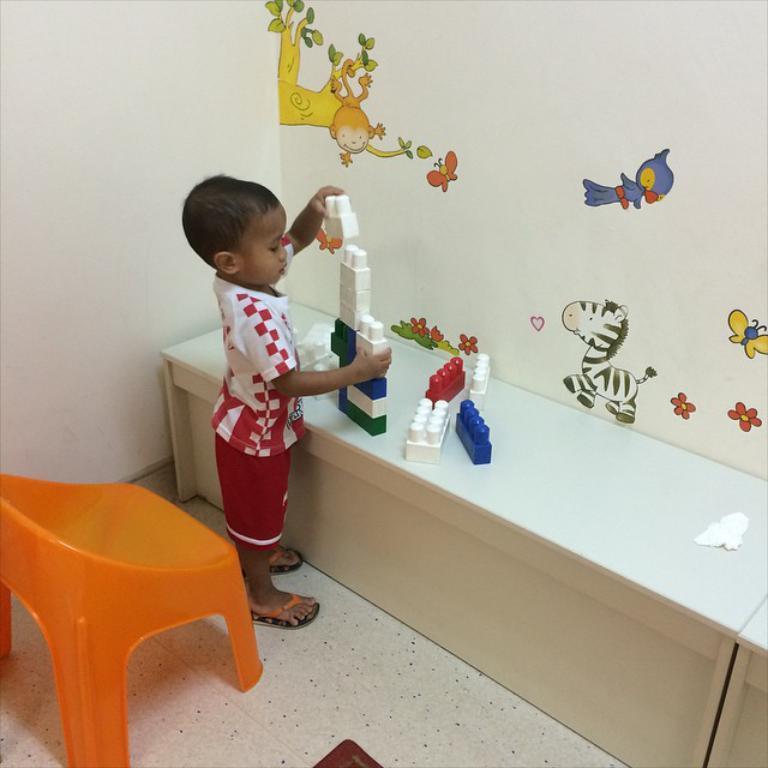In one or two sentences, can you explain what this image depicts? This is a picture of a kid playing with toys, on the left there is a chair. Wall is painted with animals. In the center there is a desk. 